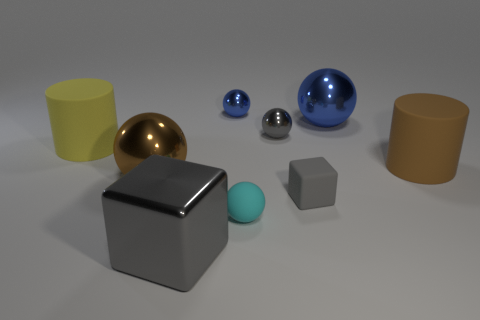The cube that is made of the same material as the small gray sphere is what color?
Your answer should be compact. Gray. What is the shape of the gray metal object to the right of the tiny ball in front of the cylinder that is to the left of the brown cylinder?
Make the answer very short. Sphere. The rubber cube is what size?
Give a very brief answer. Small. The brown object that is the same material as the big blue thing is what shape?
Make the answer very short. Sphere. Is the number of big blue shiny objects to the left of the small gray matte block less than the number of metal spheres?
Your response must be concise. Yes. There is a big rubber thing to the left of the brown matte cylinder; what color is it?
Keep it short and to the point. Yellow. What material is the other block that is the same color as the large metallic cube?
Your response must be concise. Rubber. Are there any brown objects that have the same shape as the large yellow object?
Provide a succinct answer. Yes. How many big yellow matte things have the same shape as the big brown matte object?
Make the answer very short. 1. Does the rubber cube have the same color as the metallic block?
Provide a succinct answer. Yes. 